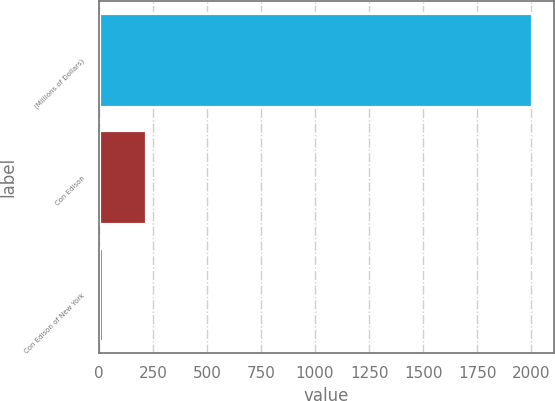<chart> <loc_0><loc_0><loc_500><loc_500><bar_chart><fcel>(Millions of Dollars)<fcel>Con Edison<fcel>Con Edison of New York<nl><fcel>2005<fcel>215.8<fcel>17<nl></chart> 